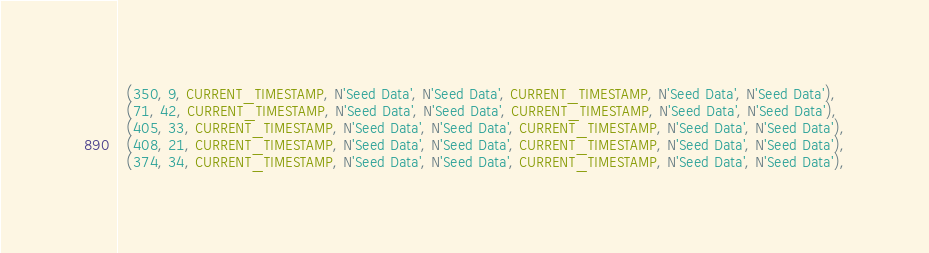<code> <loc_0><loc_0><loc_500><loc_500><_SQL_>  (350, 9, CURRENT_TIMESTAMP, N'Seed Data', N'Seed Data', CURRENT_TIMESTAMP, N'Seed Data', N'Seed Data'),
  (71, 42, CURRENT_TIMESTAMP, N'Seed Data', N'Seed Data', CURRENT_TIMESTAMP, N'Seed Data', N'Seed Data'),
  (405, 33, CURRENT_TIMESTAMP, N'Seed Data', N'Seed Data', CURRENT_TIMESTAMP, N'Seed Data', N'Seed Data'),
  (408, 21, CURRENT_TIMESTAMP, N'Seed Data', N'Seed Data', CURRENT_TIMESTAMP, N'Seed Data', N'Seed Data'),
  (374, 34, CURRENT_TIMESTAMP, N'Seed Data', N'Seed Data', CURRENT_TIMESTAMP, N'Seed Data', N'Seed Data'),</code> 